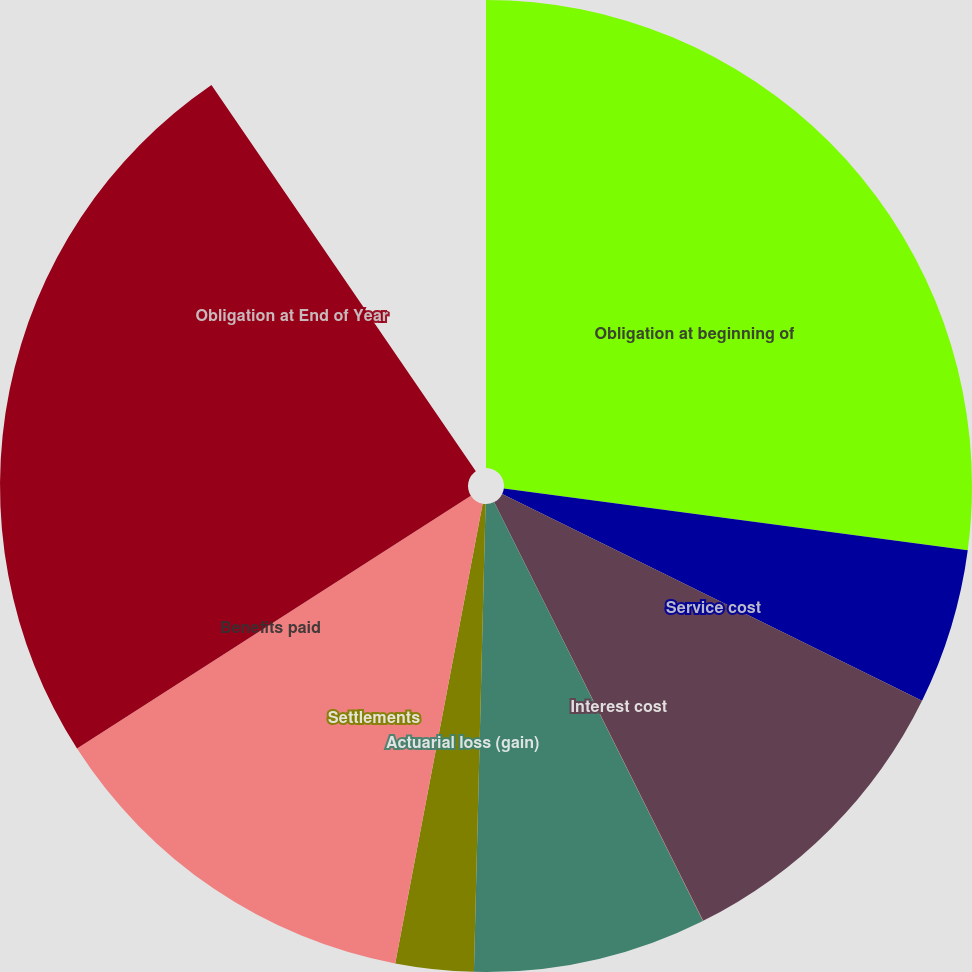Convert chart. <chart><loc_0><loc_0><loc_500><loc_500><pie_chart><fcel>Obligation at beginning of<fcel>Service cost<fcel>Interest cost<fcel>Amendments<fcel>Actuarial loss (gain)<fcel>Settlements<fcel>Benefits paid<fcel>Obligation at End of Year<nl><fcel>29.97%<fcel>5.72%<fcel>11.44%<fcel>0.01%<fcel>8.58%<fcel>2.87%<fcel>14.29%<fcel>27.12%<nl></chart> 